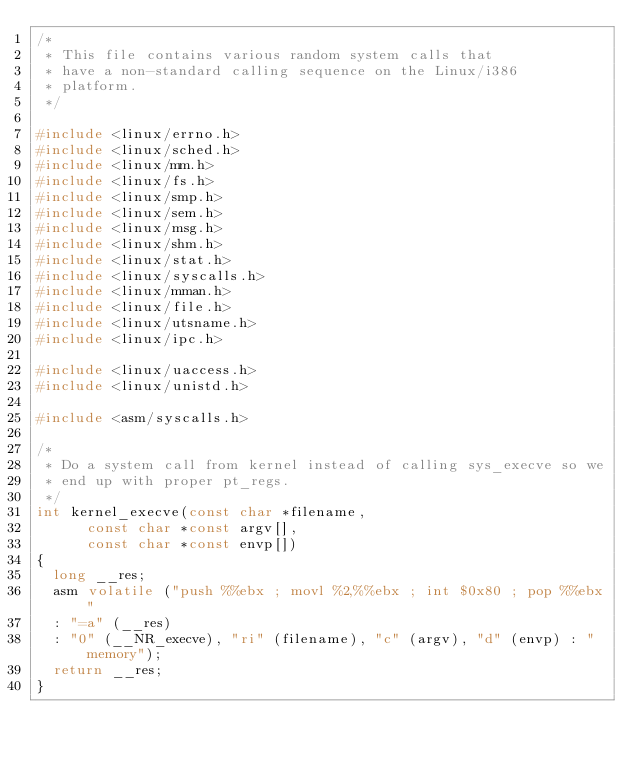Convert code to text. <code><loc_0><loc_0><loc_500><loc_500><_C_>/*
 * This file contains various random system calls that
 * have a non-standard calling sequence on the Linux/i386
 * platform.
 */

#include <linux/errno.h>
#include <linux/sched.h>
#include <linux/mm.h>
#include <linux/fs.h>
#include <linux/smp.h>
#include <linux/sem.h>
#include <linux/msg.h>
#include <linux/shm.h>
#include <linux/stat.h>
#include <linux/syscalls.h>
#include <linux/mman.h>
#include <linux/file.h>
#include <linux/utsname.h>
#include <linux/ipc.h>

#include <linux/uaccess.h>
#include <linux/unistd.h>

#include <asm/syscalls.h>

/*
 * Do a system call from kernel instead of calling sys_execve so we
 * end up with proper pt_regs.
 */
int kernel_execve(const char *filename,
		  const char *const argv[],
		  const char *const envp[])
{
	long __res;
	asm volatile ("push %%ebx ; movl %2,%%ebx ; int $0x80 ; pop %%ebx"
	: "=a" (__res)
	: "0" (__NR_execve), "ri" (filename), "c" (argv), "d" (envp) : "memory");
	return __res;
}
</code> 